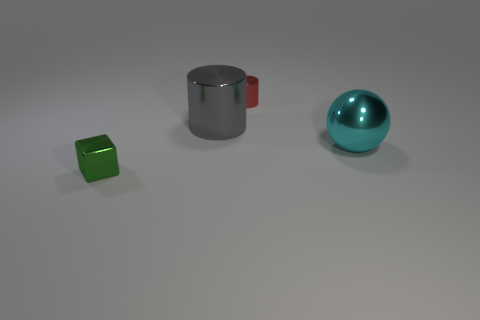Add 1 brown matte objects. How many objects exist? 5 Subtract all cubes. How many objects are left? 3 Subtract all small red things. Subtract all gray things. How many objects are left? 2 Add 2 large gray metal cylinders. How many large gray metal cylinders are left? 3 Add 2 brown blocks. How many brown blocks exist? 2 Subtract 0 purple spheres. How many objects are left? 4 